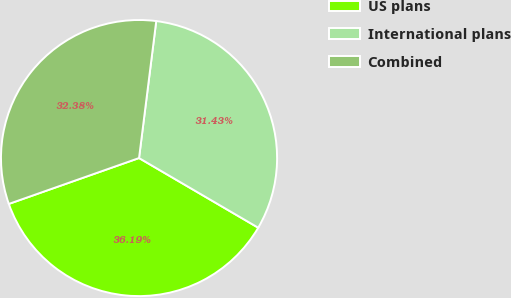<chart> <loc_0><loc_0><loc_500><loc_500><pie_chart><fcel>US plans<fcel>International plans<fcel>Combined<nl><fcel>36.19%<fcel>31.43%<fcel>32.38%<nl></chart> 